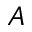Convert formula to latex. <formula><loc_0><loc_0><loc_500><loc_500>A</formula> 